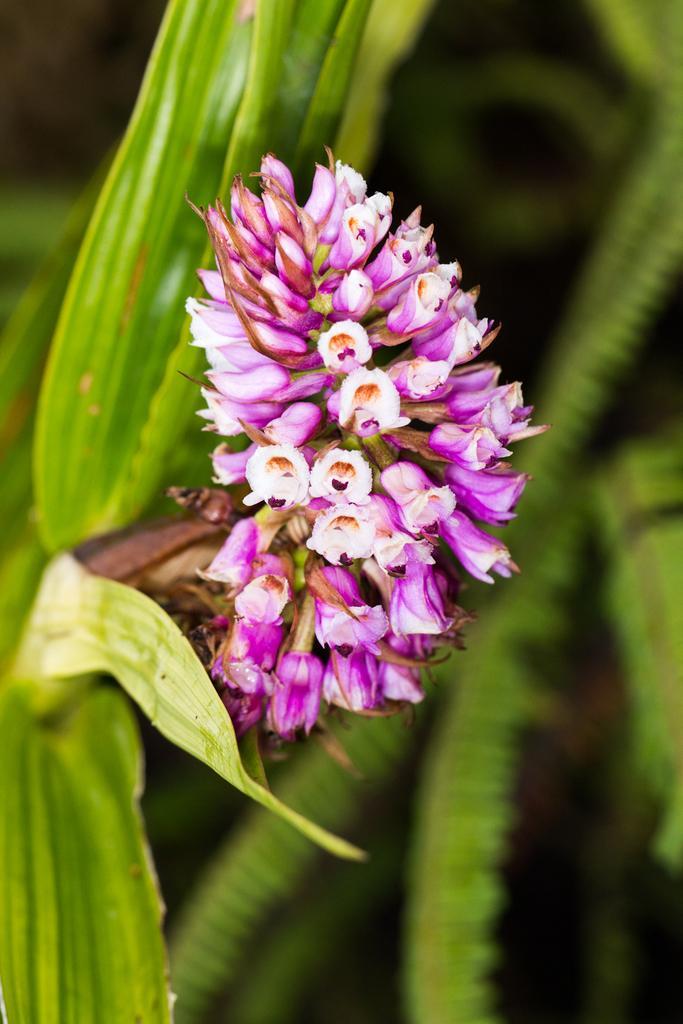Describe this image in one or two sentences. There are pink and white color flowers on a plant. In the background it is blurred. 